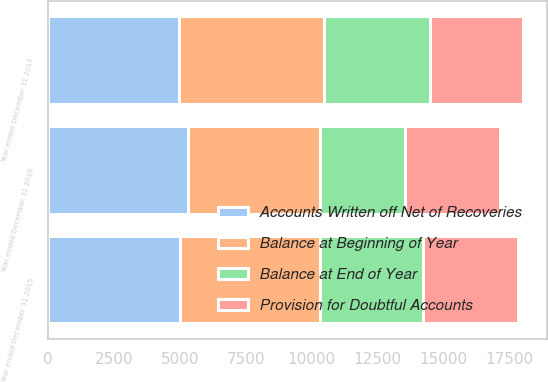Convert chart to OTSL. <chart><loc_0><loc_0><loc_500><loc_500><stacked_bar_chart><ecel><fcel>Year ended December 31 2015<fcel>Year ended December 31 2016<fcel>Year ended December 31 2017<nl><fcel>Accounts Written off Net of Recoveries<fcel>5011<fcel>5326<fcel>4988<nl><fcel>Balance at End of Year<fcel>3913<fcel>3257<fcel>4039<nl><fcel>Provision for Doubtful Accounts<fcel>3598<fcel>3595<fcel>3539<nl><fcel>Balance at Beginning of Year<fcel>5326<fcel>4988<fcel>5488<nl></chart> 